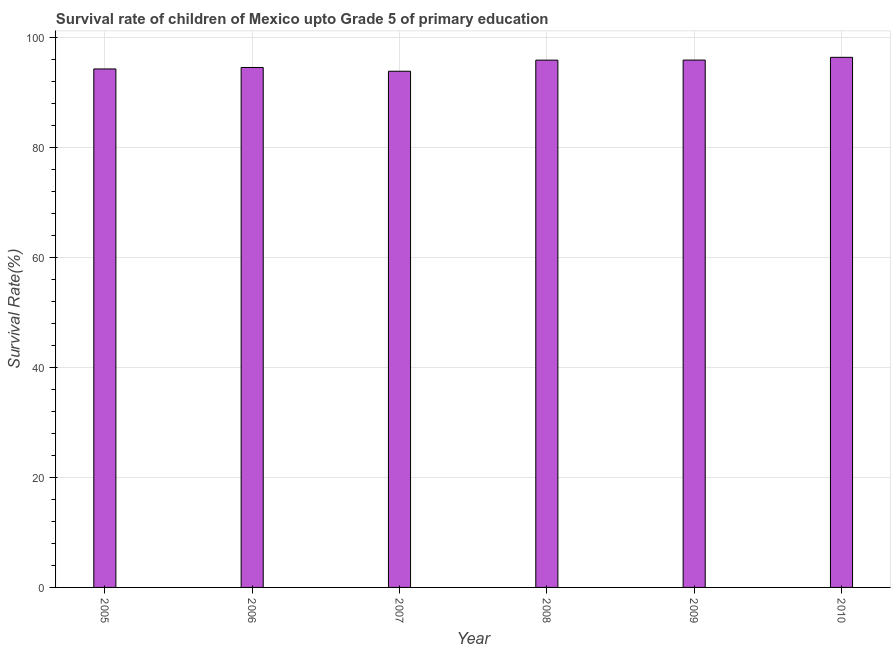What is the title of the graph?
Offer a terse response. Survival rate of children of Mexico upto Grade 5 of primary education. What is the label or title of the Y-axis?
Keep it short and to the point. Survival Rate(%). What is the survival rate in 2005?
Ensure brevity in your answer.  94.35. Across all years, what is the maximum survival rate?
Make the answer very short. 96.47. Across all years, what is the minimum survival rate?
Your response must be concise. 93.94. In which year was the survival rate maximum?
Your answer should be very brief. 2010. In which year was the survival rate minimum?
Your answer should be very brief. 2007. What is the sum of the survival rate?
Keep it short and to the point. 571.3. What is the difference between the survival rate in 2005 and 2008?
Keep it short and to the point. -1.6. What is the average survival rate per year?
Your response must be concise. 95.22. What is the median survival rate?
Your answer should be very brief. 95.29. What is the ratio of the survival rate in 2005 to that in 2009?
Your answer should be compact. 0.98. Is the survival rate in 2006 less than that in 2008?
Make the answer very short. Yes. What is the difference between the highest and the second highest survival rate?
Your answer should be very brief. 0.5. Is the sum of the survival rate in 2005 and 2009 greater than the maximum survival rate across all years?
Your response must be concise. Yes. What is the difference between the highest and the lowest survival rate?
Your answer should be compact. 2.53. In how many years, is the survival rate greater than the average survival rate taken over all years?
Provide a succinct answer. 3. How many bars are there?
Provide a short and direct response. 6. How many years are there in the graph?
Ensure brevity in your answer.  6. What is the difference between two consecutive major ticks on the Y-axis?
Your answer should be very brief. 20. What is the Survival Rate(%) of 2005?
Your answer should be compact. 94.35. What is the Survival Rate(%) of 2006?
Provide a succinct answer. 94.62. What is the Survival Rate(%) of 2007?
Offer a very short reply. 93.94. What is the Survival Rate(%) of 2008?
Offer a very short reply. 95.96. What is the Survival Rate(%) in 2009?
Make the answer very short. 95.97. What is the Survival Rate(%) of 2010?
Make the answer very short. 96.47. What is the difference between the Survival Rate(%) in 2005 and 2006?
Your answer should be compact. -0.27. What is the difference between the Survival Rate(%) in 2005 and 2007?
Provide a short and direct response. 0.42. What is the difference between the Survival Rate(%) in 2005 and 2008?
Provide a short and direct response. -1.61. What is the difference between the Survival Rate(%) in 2005 and 2009?
Provide a short and direct response. -1.62. What is the difference between the Survival Rate(%) in 2005 and 2010?
Your answer should be compact. -2.11. What is the difference between the Survival Rate(%) in 2006 and 2007?
Make the answer very short. 0.69. What is the difference between the Survival Rate(%) in 2006 and 2008?
Ensure brevity in your answer.  -1.34. What is the difference between the Survival Rate(%) in 2006 and 2009?
Your answer should be compact. -1.35. What is the difference between the Survival Rate(%) in 2006 and 2010?
Your response must be concise. -1.85. What is the difference between the Survival Rate(%) in 2007 and 2008?
Ensure brevity in your answer.  -2.02. What is the difference between the Survival Rate(%) in 2007 and 2009?
Ensure brevity in your answer.  -2.03. What is the difference between the Survival Rate(%) in 2007 and 2010?
Give a very brief answer. -2.53. What is the difference between the Survival Rate(%) in 2008 and 2009?
Give a very brief answer. -0.01. What is the difference between the Survival Rate(%) in 2008 and 2010?
Offer a terse response. -0.51. What is the difference between the Survival Rate(%) in 2009 and 2010?
Ensure brevity in your answer.  -0.5. What is the ratio of the Survival Rate(%) in 2005 to that in 2006?
Your response must be concise. 1. What is the ratio of the Survival Rate(%) in 2005 to that in 2007?
Your response must be concise. 1. What is the ratio of the Survival Rate(%) in 2005 to that in 2009?
Your answer should be compact. 0.98. What is the ratio of the Survival Rate(%) in 2005 to that in 2010?
Your answer should be very brief. 0.98. What is the ratio of the Survival Rate(%) in 2006 to that in 2009?
Ensure brevity in your answer.  0.99. What is the ratio of the Survival Rate(%) in 2006 to that in 2010?
Provide a succinct answer. 0.98. What is the ratio of the Survival Rate(%) in 2007 to that in 2008?
Offer a very short reply. 0.98. What is the ratio of the Survival Rate(%) in 2007 to that in 2009?
Provide a succinct answer. 0.98. 